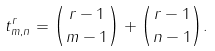<formula> <loc_0><loc_0><loc_500><loc_500>t ^ { r } _ { m , n } = \binom { r - 1 } { m - 1 } + \binom { r - 1 } { n - 1 } .</formula> 